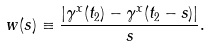<formula> <loc_0><loc_0><loc_500><loc_500>w ( s ) \equiv \frac { | \gamma ^ { x } ( t _ { 2 } ) - \gamma ^ { x } ( t _ { 2 } - s ) | } { s } .</formula> 